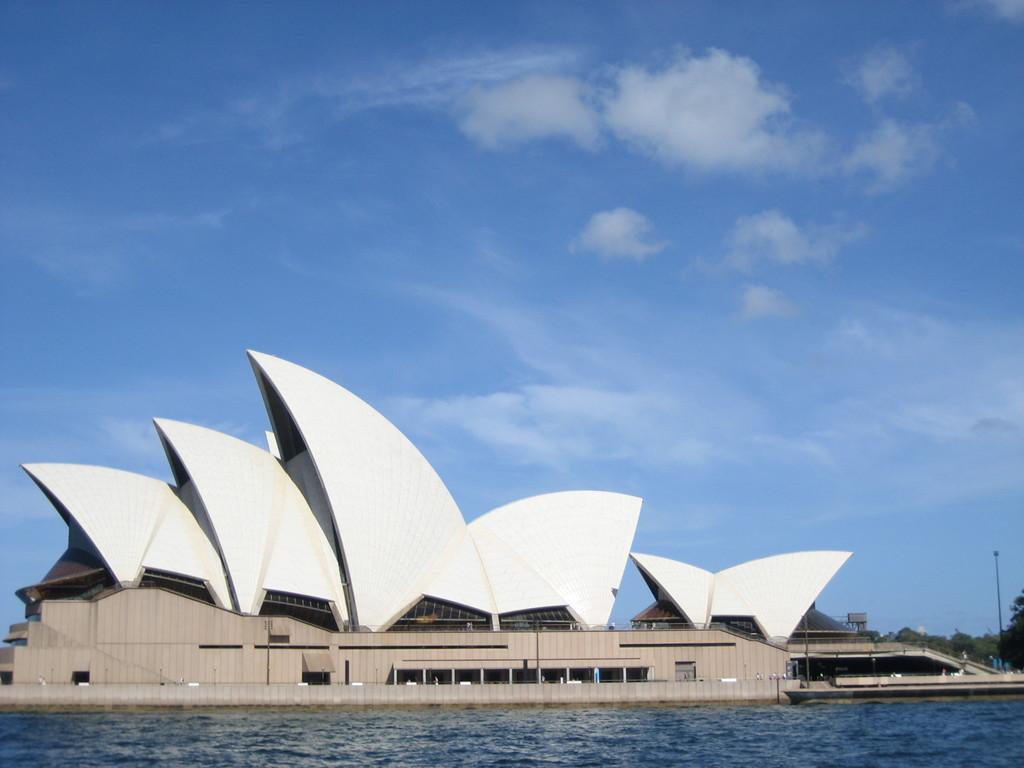Describe this image in one or two sentences. In this image I can see water and Sydney Opera House. In background I can see few trees, clouds and the sky. 